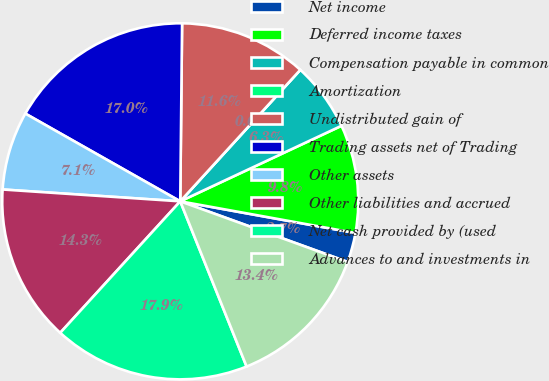Convert chart to OTSL. <chart><loc_0><loc_0><loc_500><loc_500><pie_chart><fcel>Net income<fcel>Deferred income taxes<fcel>Compensation payable in common<fcel>Amortization<fcel>Undistributed gain of<fcel>Trading assets net of Trading<fcel>Other assets<fcel>Other liabilities and accrued<fcel>Net cash provided by (used<fcel>Advances to and investments in<nl><fcel>2.68%<fcel>9.82%<fcel>6.25%<fcel>0.0%<fcel>11.61%<fcel>16.96%<fcel>7.14%<fcel>14.28%<fcel>17.85%<fcel>13.39%<nl></chart> 